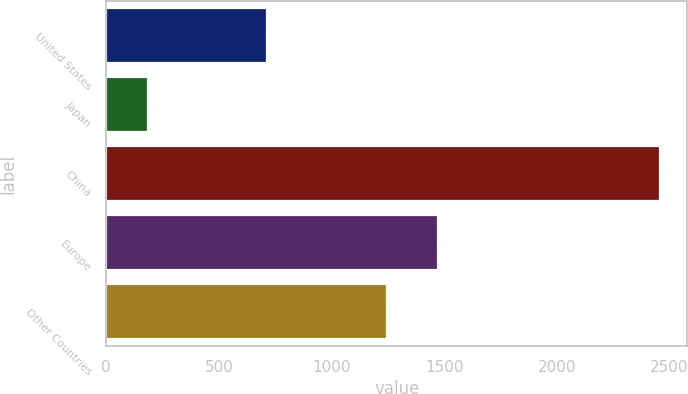Convert chart. <chart><loc_0><loc_0><loc_500><loc_500><bar_chart><fcel>United States<fcel>Japan<fcel>China<fcel>Europe<fcel>Other Countries<nl><fcel>715<fcel>185<fcel>2456<fcel>1474.1<fcel>1247<nl></chart> 